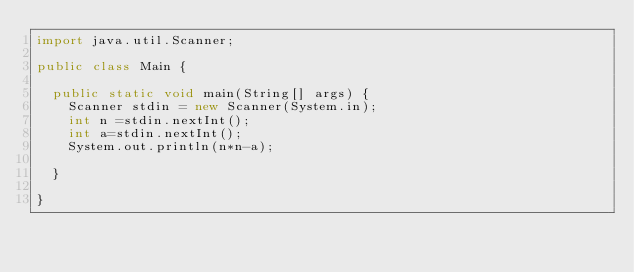<code> <loc_0><loc_0><loc_500><loc_500><_Java_>import java.util.Scanner;

public class Main {

	public static void main(String[] args) {
		Scanner stdin = new Scanner(System.in);
		int n =stdin.nextInt();
		int a=stdin.nextInt();
		System.out.println(n*n-a);
		
	}

}
</code> 